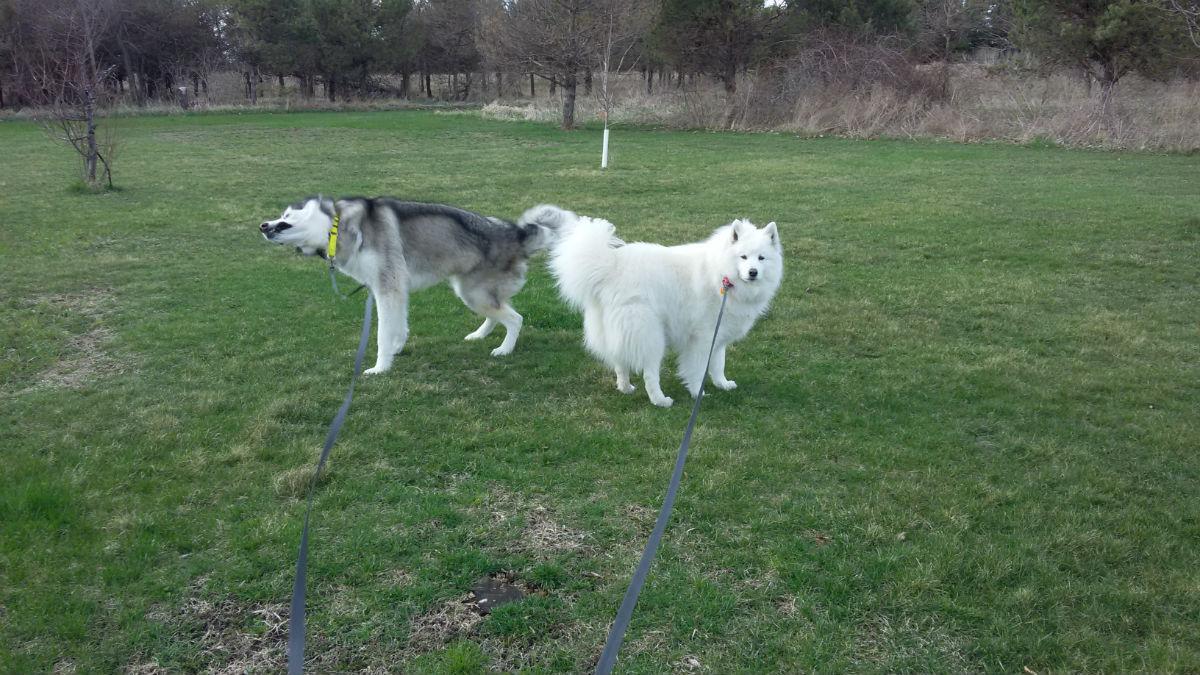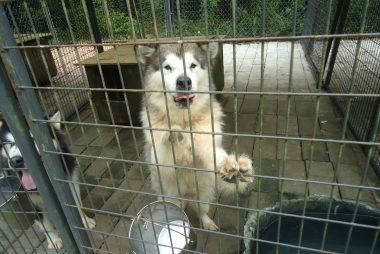The first image is the image on the left, the second image is the image on the right. For the images displayed, is the sentence "One image shows at least one dog in a wire-covered kennel, and the other image shows a dog with 'salt and pepper' coloring on the left of a paler dog." factually correct? Answer yes or no. Yes. The first image is the image on the left, the second image is the image on the right. Given the left and right images, does the statement "At least one dog is standing on grass." hold true? Answer yes or no. Yes. 